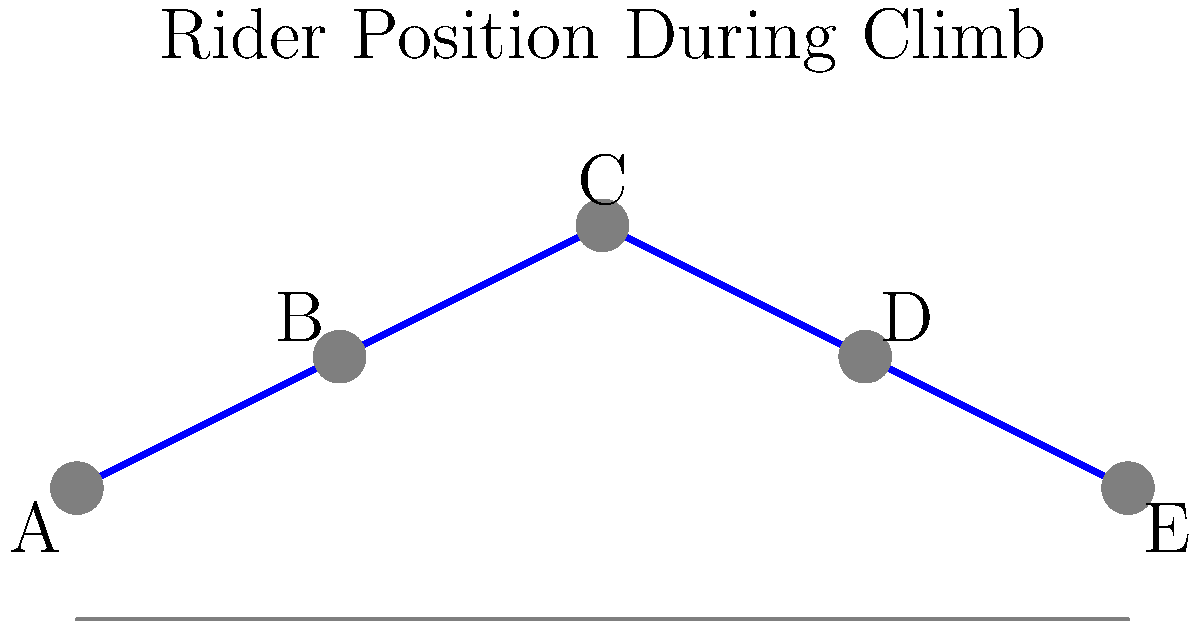Based on the diagram showing a rider's position during a climb, which position (A, B, C, D, or E) best represents the moment when Andy Hampsten would likely exert maximum power during a steep ascent in the 1988 Giro d'Italia? To answer this question, we need to analyze the rider's position during a climb and relate it to Andy Hampsten's riding style and the conditions of the 1988 Giro d'Italia:

1. Position A: The rider is at the lowest point, representing the beginning of the pedal stroke. This is not the optimal position for maximum power output.

2. Position B: The rider is moving upward, approaching the highest point. This position allows for increasing power output but is not yet at the maximum.

3. Position C: The rider is at the highest point of the pedal stroke. This position represents the moment of maximum extension and is typically where cyclists exert the most force.

4. Position D: The rider is moving downward, past the highest point. Power output begins to decrease in this position.

5. Position E: The rider is at the end of the pedal stroke, preparing to begin the next cycle. This position has the least power output.

Considering Andy Hampsten's climbing prowess, particularly during his 1988 Giro d'Italia victory, he would likely exert maximum power at the highest point of the pedal stroke. This allows for the greatest force to be applied to the pedals, especially on steep ascents where maintaining momentum is crucial.

Therefore, position C represents the moment when Andy Hampsten would likely exert maximum power during a steep climb in the 1988 Giro d'Italia.
Answer: C 